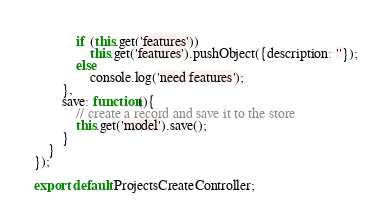Convert code to text. <code><loc_0><loc_0><loc_500><loc_500><_JavaScript_>			if (this.get('features'))
				this.get('features').pushObject({description: ''});
			else
				console.log('need features');
		},
		save: function(){
			// create a record and save it to the store
			this.get('model').save();
		}
	}
});

export default ProjectsCreateController;</code> 